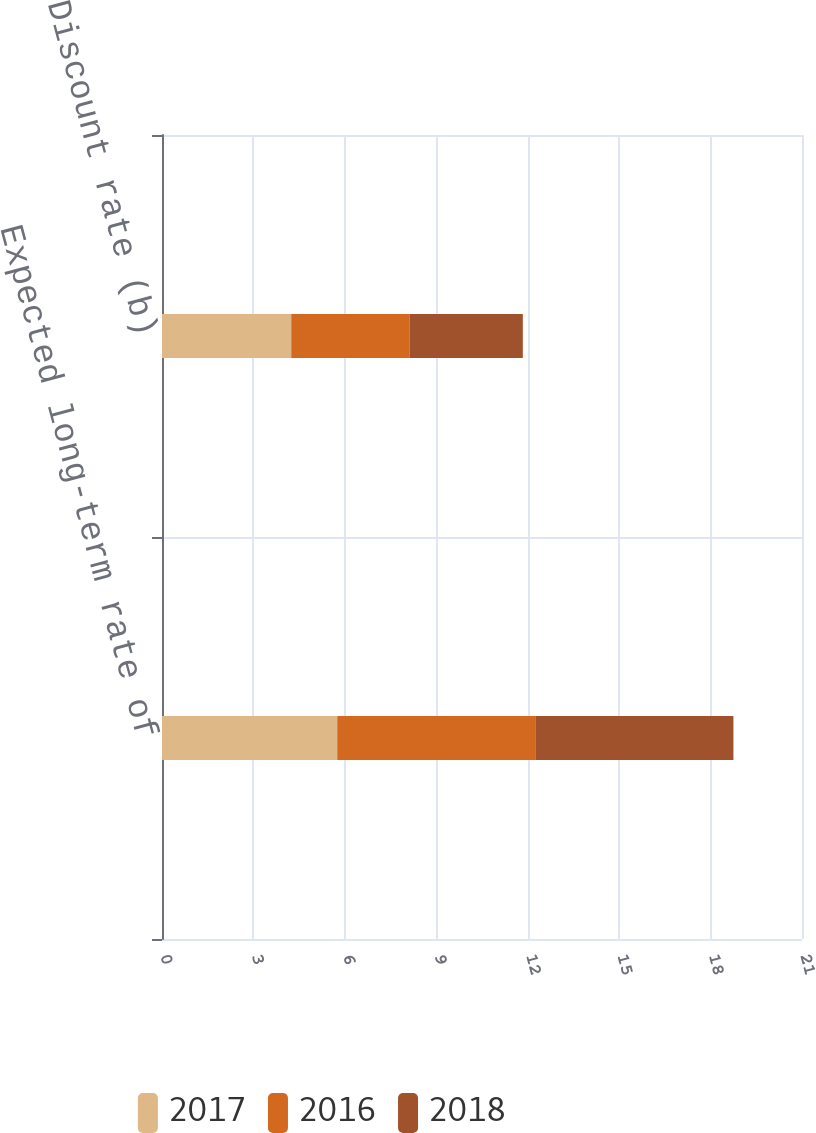Convert chart to OTSL. <chart><loc_0><loc_0><loc_500><loc_500><stacked_bar_chart><ecel><fcel>Expected long-term rate of<fcel>Discount rate (b)<nl><fcel>2017<fcel>5.75<fcel>4.24<nl><fcel>2016<fcel>6.5<fcel>3.88<nl><fcel>2018<fcel>6.5<fcel>3.72<nl></chart> 